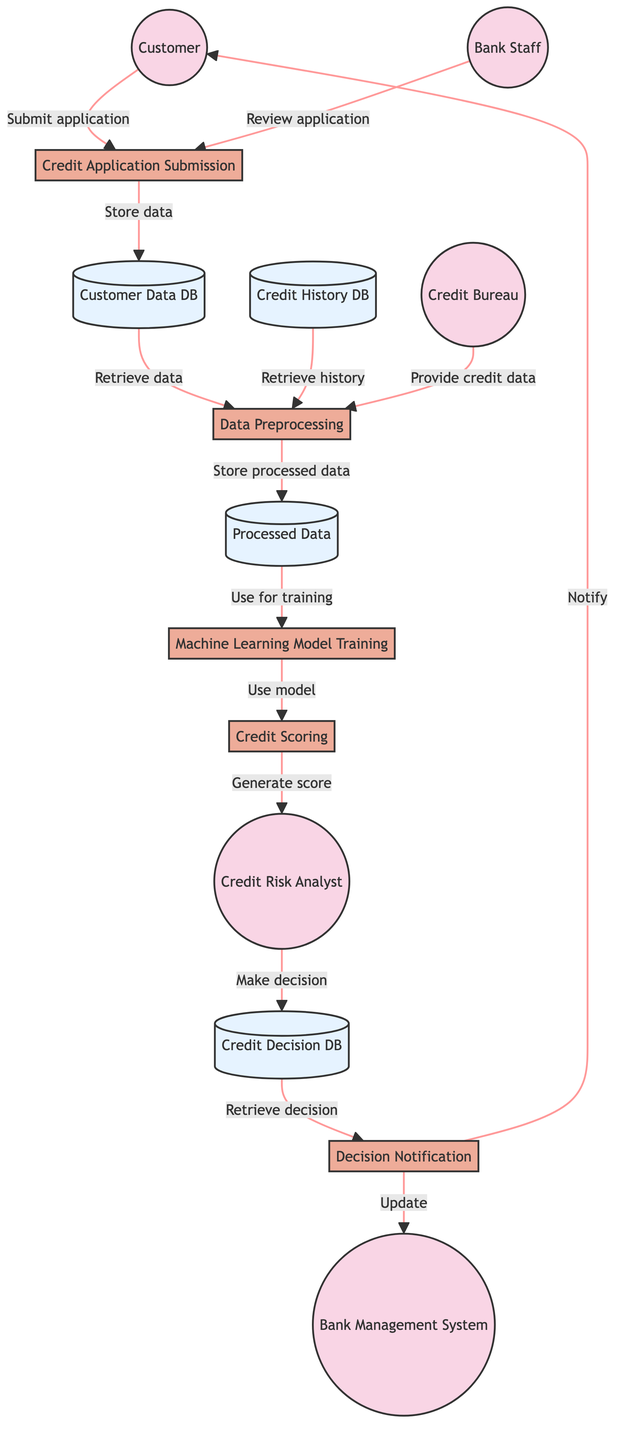What's the total number of external entities in the diagram? There are five external entities shown in the diagram. They include Customer, Bank Staff, Credit Bureau, Credit Risk Analyst, and Bank Management System.
Answer: Five Which process is responsible for collecting the customer's credit application? The process that collects the customer's credit application is titled "Credit Application Submission." This is indicated in the diagram, connecting the Customer to this process.
Answer: Credit Application Submission How many data stores are present in the diagram? There are four data stores in the diagram: Customer Data Database, Credit History Database, Processed Data, and Credit Decision Database.
Answer: Four What data source provides additional credit data for the Data Preprocessing process? The Credit Bureau provides additional credit data to the Data Preprocessing process as indicated in the flow from Credit Bureau to Data Preprocessing.
Answer: Credit Bureau Which process generates the credit score for the applicant? The process responsible for generating the credit score for the applicant is "Credit Scoring." This is the designated step where the machine learning model generates the credit score based on processed data.
Answer: Credit Scoring Who evaluates the credit risk based on the generated credit score? The Credit Risk Analyst evaluates the credit risk based on the generated credit score. This is evident from the flow leading from Credit Scoring to Credit Risk Analyst.
Answer: Credit Risk Analyst Where is the final credit decision stored? The final credit decision is stored in the Credit Decision Database as indicated in the flow leading into this data store from the Credit Risk Analyst.
Answer: Credit Decision Database What is the output of the process "Decision Notification"? The output of the process "Decision Notification" is to notify the Customer about the credit application decision as well as to update the Bank Management System.
Answer: Notify Customer What process uses the cleaned and transformed data for training? The process that utilizes the cleaned and transformed data for training is "Machine Learning Model Training." This process directly follows the Processed Data data store.
Answer: Machine Learning Model Training 